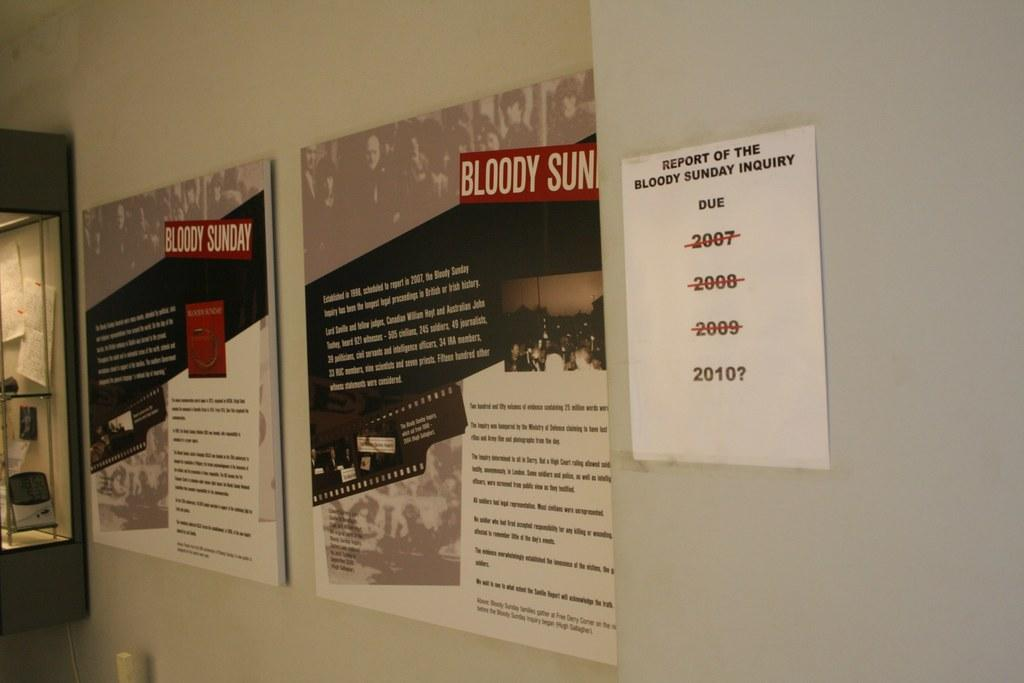<image>
Give a short and clear explanation of the subsequent image. A white piece of paper titled Report of the Bloody Sunday Inquiry is taped to the wall. 